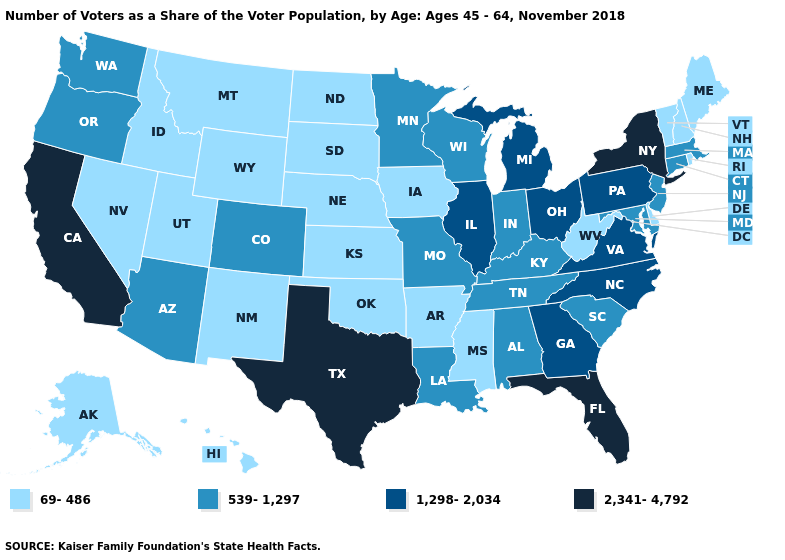Which states have the highest value in the USA?
Concise answer only. California, Florida, New York, Texas. How many symbols are there in the legend?
Be succinct. 4. Which states have the highest value in the USA?
Concise answer only. California, Florida, New York, Texas. Does Texas have the highest value in the USA?
Give a very brief answer. Yes. What is the lowest value in the USA?
Quick response, please. 69-486. Does Missouri have the highest value in the USA?
Concise answer only. No. Among the states that border Ohio , does Michigan have the highest value?
Answer briefly. Yes. What is the value of New Mexico?
Short answer required. 69-486. Which states have the lowest value in the Northeast?
Give a very brief answer. Maine, New Hampshire, Rhode Island, Vermont. What is the lowest value in the MidWest?
Give a very brief answer. 69-486. Does Massachusetts have the lowest value in the Northeast?
Answer briefly. No. Does Maine have a lower value than Kentucky?
Be succinct. Yes. Among the states that border North Carolina , which have the lowest value?
Write a very short answer. South Carolina, Tennessee. What is the lowest value in the USA?
Short answer required. 69-486. 